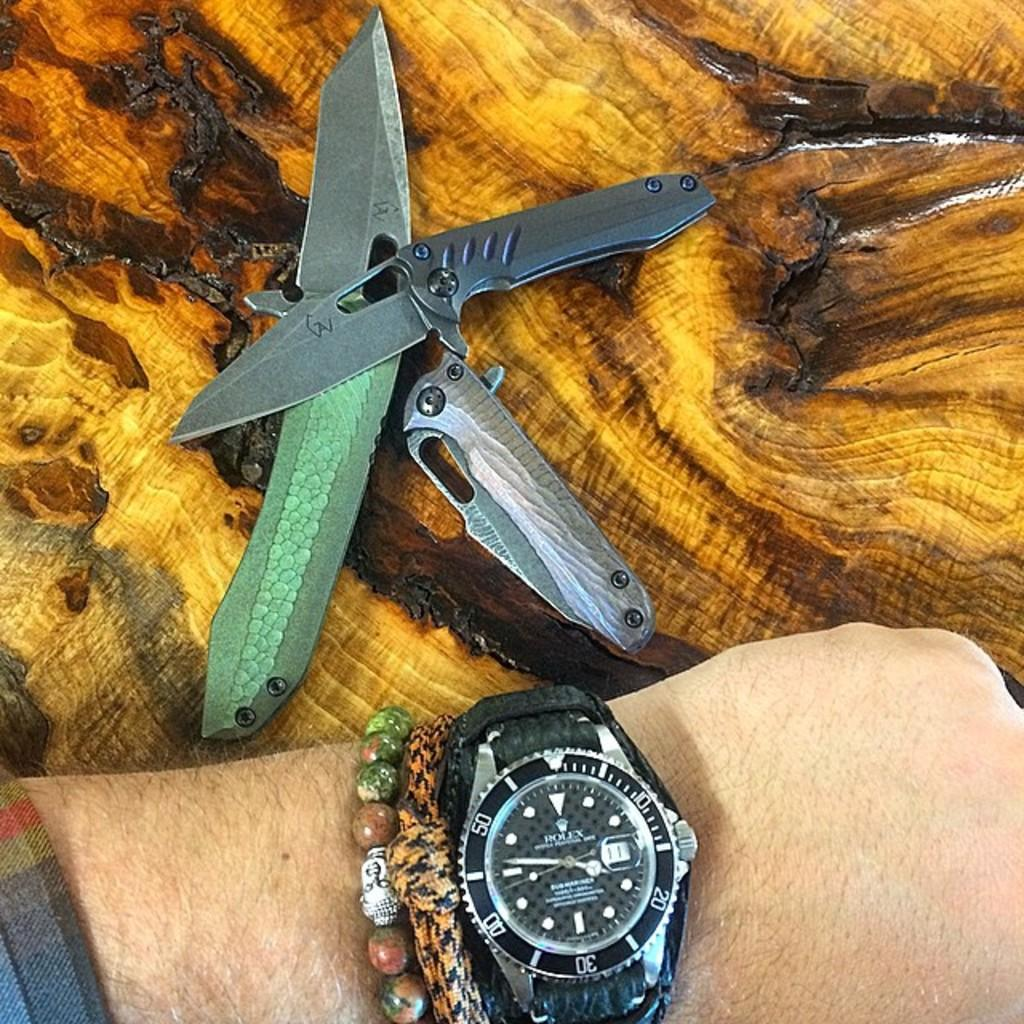<image>
Provide a brief description of the given image. A Rolex watch has a black face and is on the wrist of a man. 